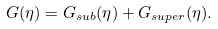<formula> <loc_0><loc_0><loc_500><loc_500>G ( \eta ) = G _ { s u b } ( \eta ) + G _ { s u p e r } ( \eta ) .</formula> 